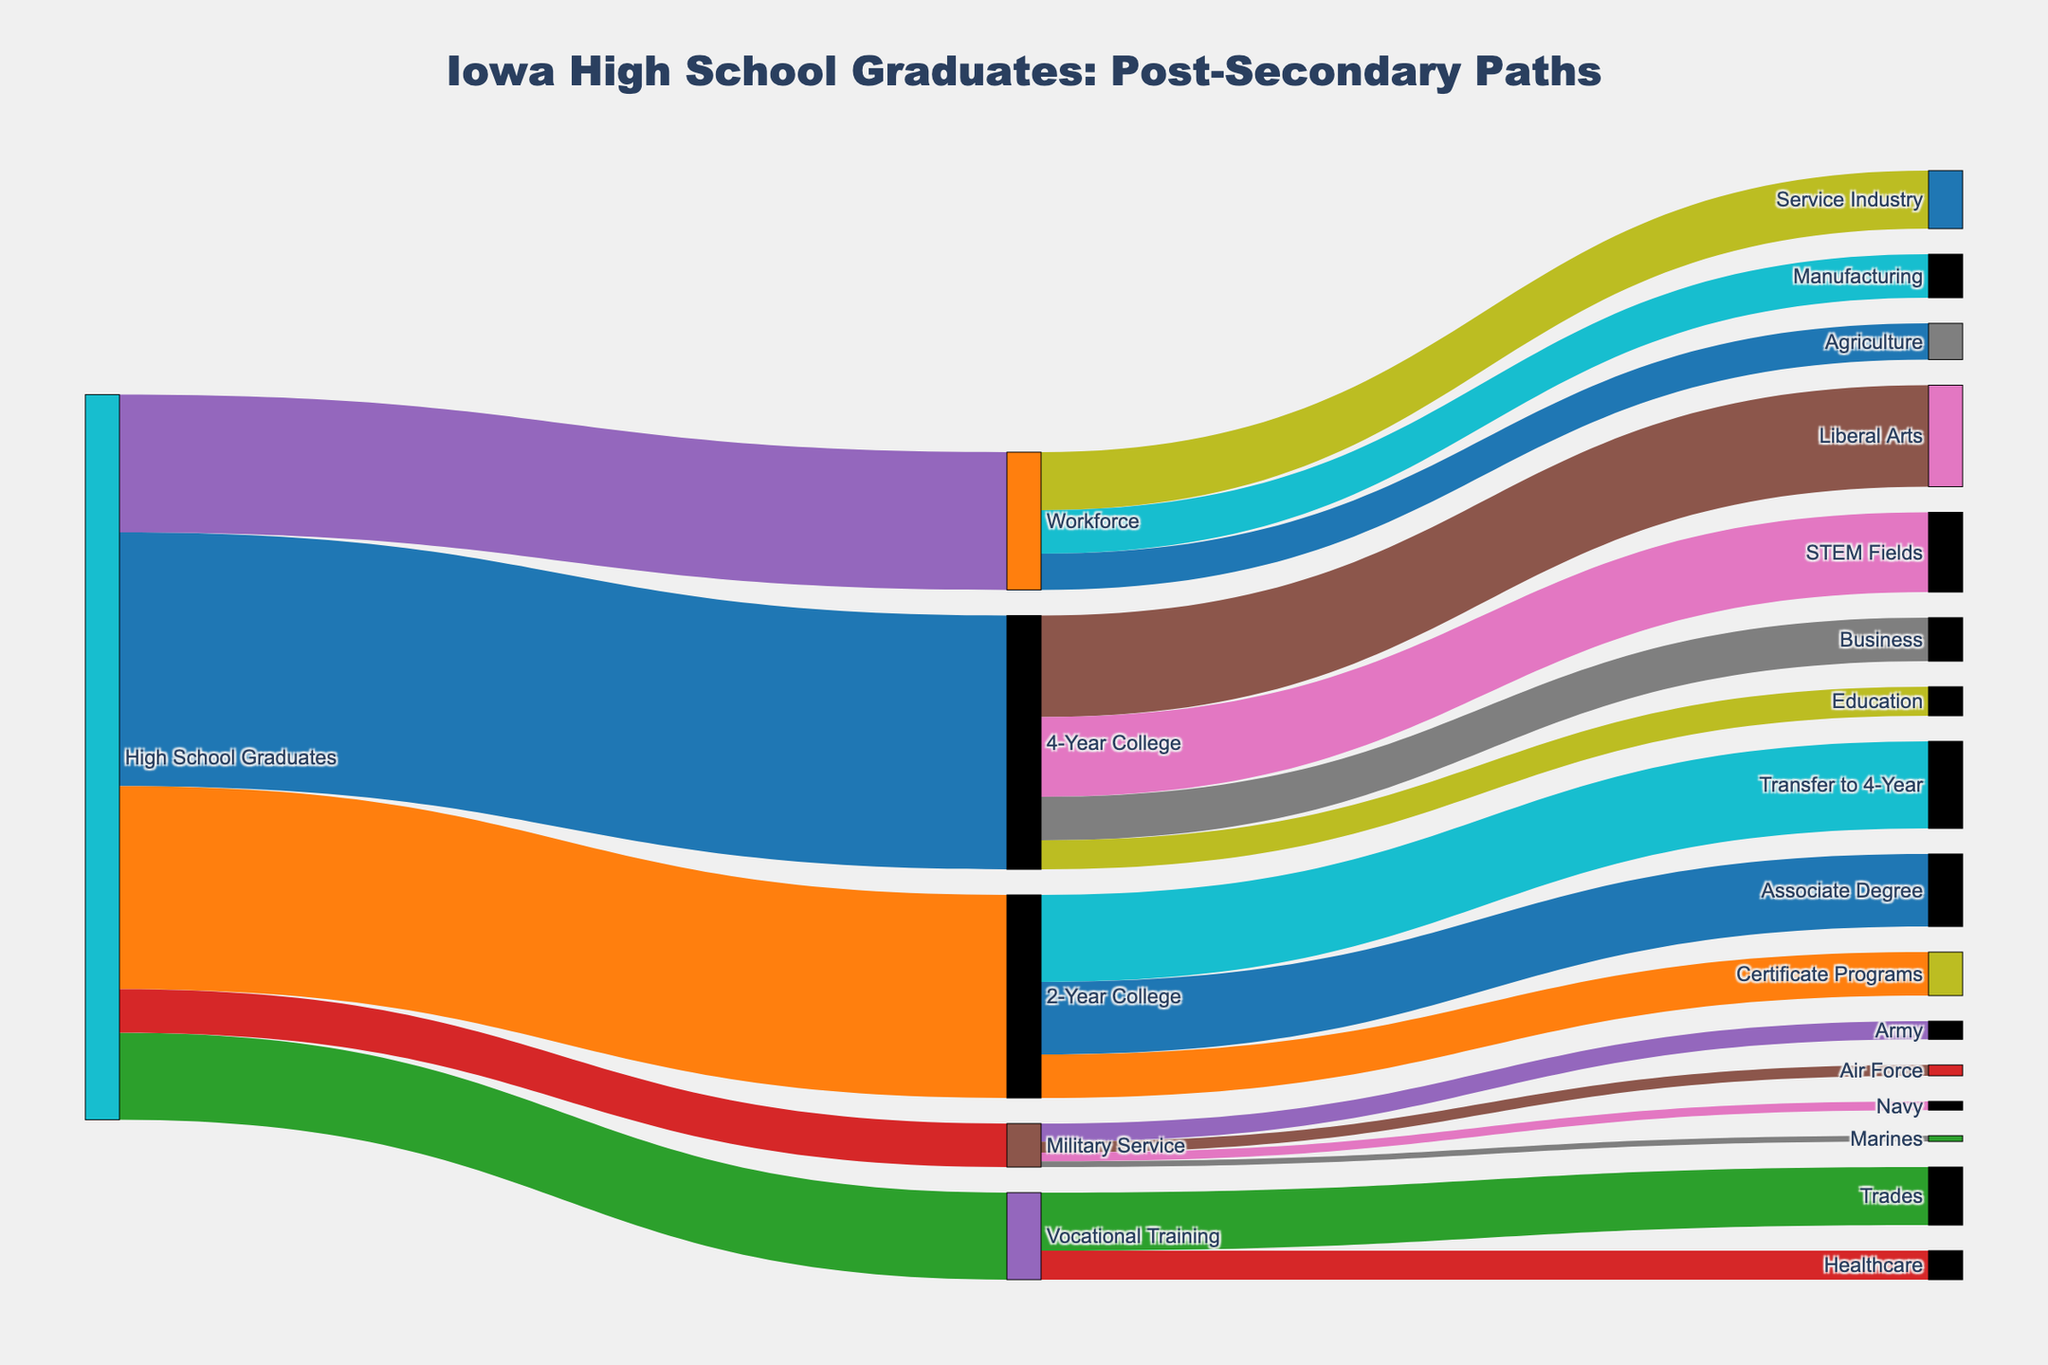What is the title of the Sankey diagram? The title can be found at the top of the figure. It is "Iowa High School Graduates: Post-Secondary Paths".
Answer: Iowa High School Graduates: Post-Secondary Paths Which post-secondary education path has the highest number of graduates? By looking at the links from "High School Graduates" to their respective paths, "4-Year College" has the highest value of 3500.
Answer: 4-Year College How many graduates chose to join the military service? The number of graduates choosing "Military Service" can be directly seen from the link labeled from "High School Graduates" to "Military Service" which has the value 600.
Answer: 600 Compare the number of graduates opting for the workforce versus those going to vocational training. Which path has more graduates? By examining the links from "High School Graduates" to "Workforce" and "Vocational Training", the Workforce path has 1900 graduates, and Vocational Training has 1200 graduates. Therefore, the Workforce path has more graduates.
Answer: Workforce How many graduates specifically went to an education program at a 4-year college? The number of graduates in the education program can be directly seen in the link from "4-Year College" to "Education" which has a value of 400.
Answer: 400 What is the combined total of graduates choosing either Liberal Arts or STEM Fields after a 4-year college? The values for "Liberal Arts" (1400) and "STEM Fields" (1100) from "4-Year College" should be summed up: 1400 + 1100 = 2500.
Answer: 2500 Which branch of the military has the fewest high school graduates? The branches of the military are Army, Air Force, Navy, and Marines. The link values are 250, 150, 120, and 80, respectively. Thus, the Marines have the fewest graduates.
Answer: Marines How does the number of students transferring from a 2-year college to a 4-year college compare with those earning an associate degree? In the Sankey diagram, the number of students transferring to a 4-year college is 1200, while those earning an associate degree is 1000. Therefore, more students transfer to a 4-year college.
Answer: Transferring to 4-Year College What percentage of high school graduates went into the workforce? To get the percentage, divide the number of graduates entering the workforce (1900) by the total high school graduates (sum all the links from "High School Graduates"): 3500 + 2800 + 1200 + 600 + 1900 = 10,000. The percentage is (1900 / 10000) * 100 = 19%.
Answer: 19% Is the number of students entering certificate programs at 2-year colleges higher or lower than those entering healthcare vocational training? The Sankey diagram shows 600 students entering certificate programs and 400 students entering healthcare vocational training. Therefore, more students enter certificate programs.
Answer: Higher 